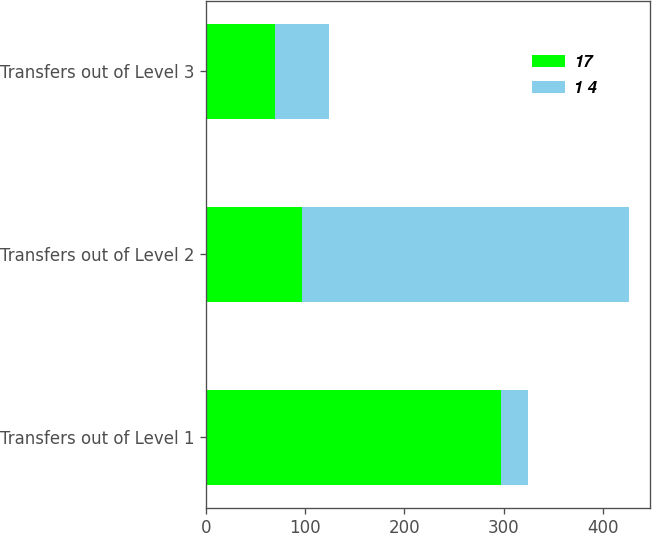<chart> <loc_0><loc_0><loc_500><loc_500><stacked_bar_chart><ecel><fcel>Transfers out of Level 1<fcel>Transfers out of Level 2<fcel>Transfers out of Level 3<nl><fcel>17<fcel>297<fcel>97<fcel>69<nl><fcel>1 4<fcel>28<fcel>329<fcel>55<nl></chart> 